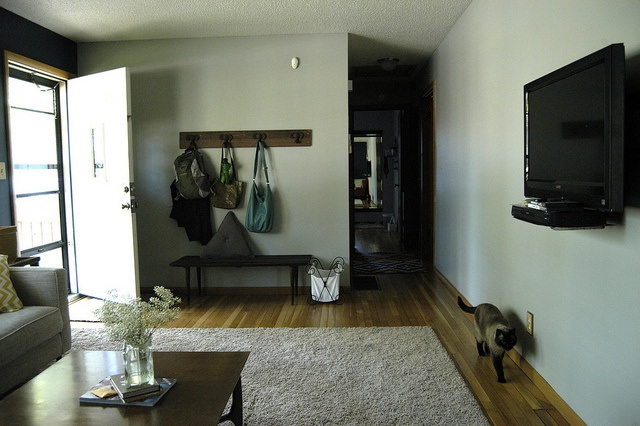Describe the objects in this image and their specific colors. I can see tv in gray, black, olive, and darkgray tones, couch in gray, black, darkgreen, and darkgray tones, cat in gray, black, and darkgreen tones, backpack in gray, black, and darkgreen tones, and book in gray, black, darkgray, and blue tones in this image. 